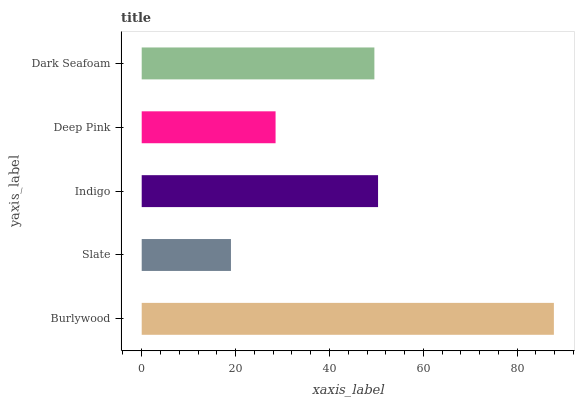Is Slate the minimum?
Answer yes or no. Yes. Is Burlywood the maximum?
Answer yes or no. Yes. Is Indigo the minimum?
Answer yes or no. No. Is Indigo the maximum?
Answer yes or no. No. Is Indigo greater than Slate?
Answer yes or no. Yes. Is Slate less than Indigo?
Answer yes or no. Yes. Is Slate greater than Indigo?
Answer yes or no. No. Is Indigo less than Slate?
Answer yes or no. No. Is Dark Seafoam the high median?
Answer yes or no. Yes. Is Dark Seafoam the low median?
Answer yes or no. Yes. Is Slate the high median?
Answer yes or no. No. Is Burlywood the low median?
Answer yes or no. No. 